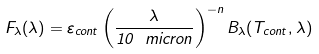Convert formula to latex. <formula><loc_0><loc_0><loc_500><loc_500>F _ { \lambda } ( \lambda ) = \varepsilon _ { c o n t } \left ( \frac { \lambda } { 1 0 { \ m i c r o n } } \right ) ^ { - n } B _ { \lambda } ( T _ { c o n t } , \lambda )</formula> 